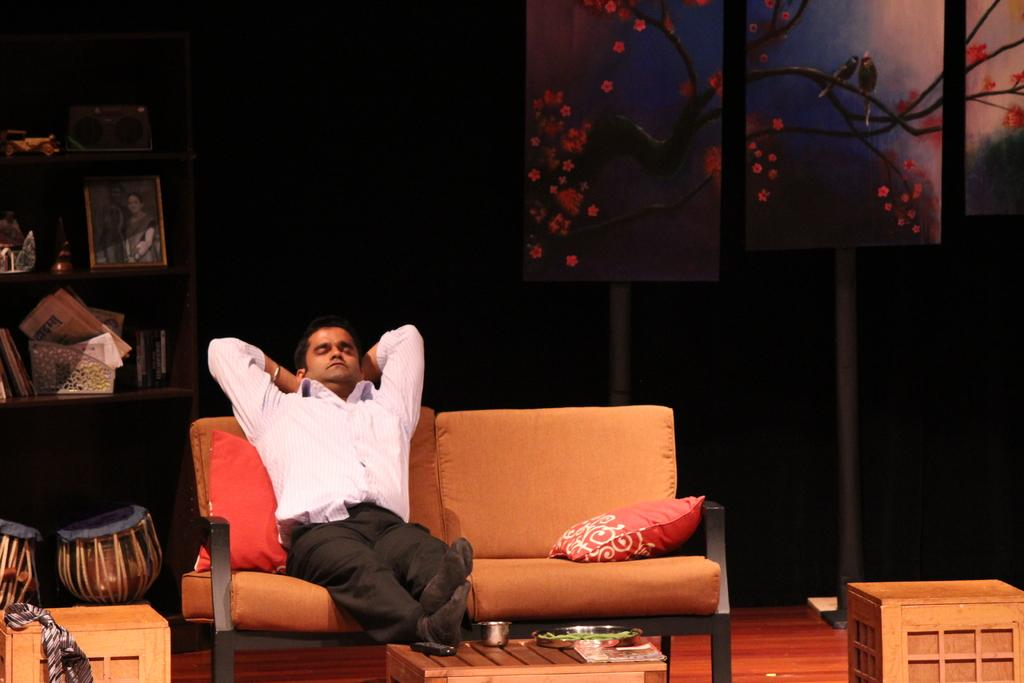What is the person in the image doing? The person is sitting on a sofa in the room. Can you describe any other items present in the room? Unfortunately, the provided facts do not specify any other items present in the room. What type of wax can be seen melting in the scene? There is no wax present in the image, nor is there any indication of a scene. 